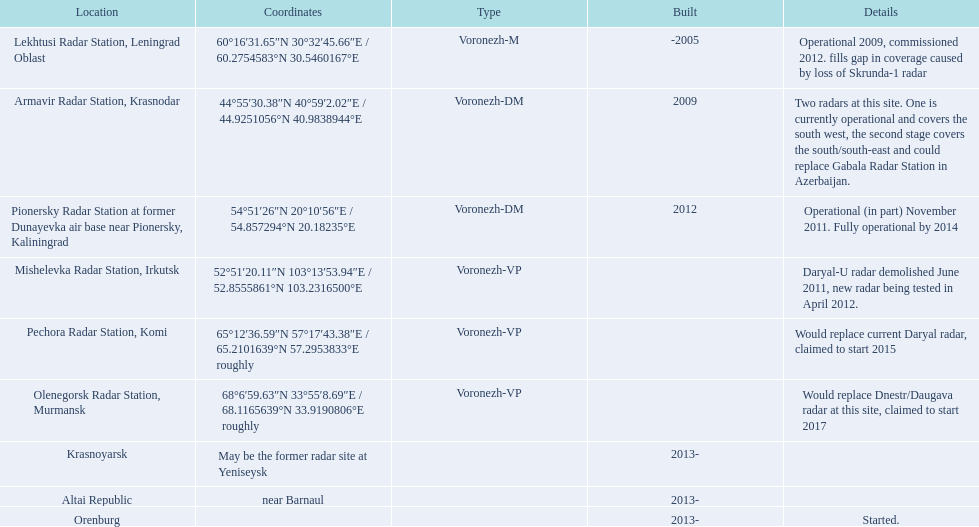In 2015, what is the only radar that will be initiated? Pechora Radar Station, Komi. 